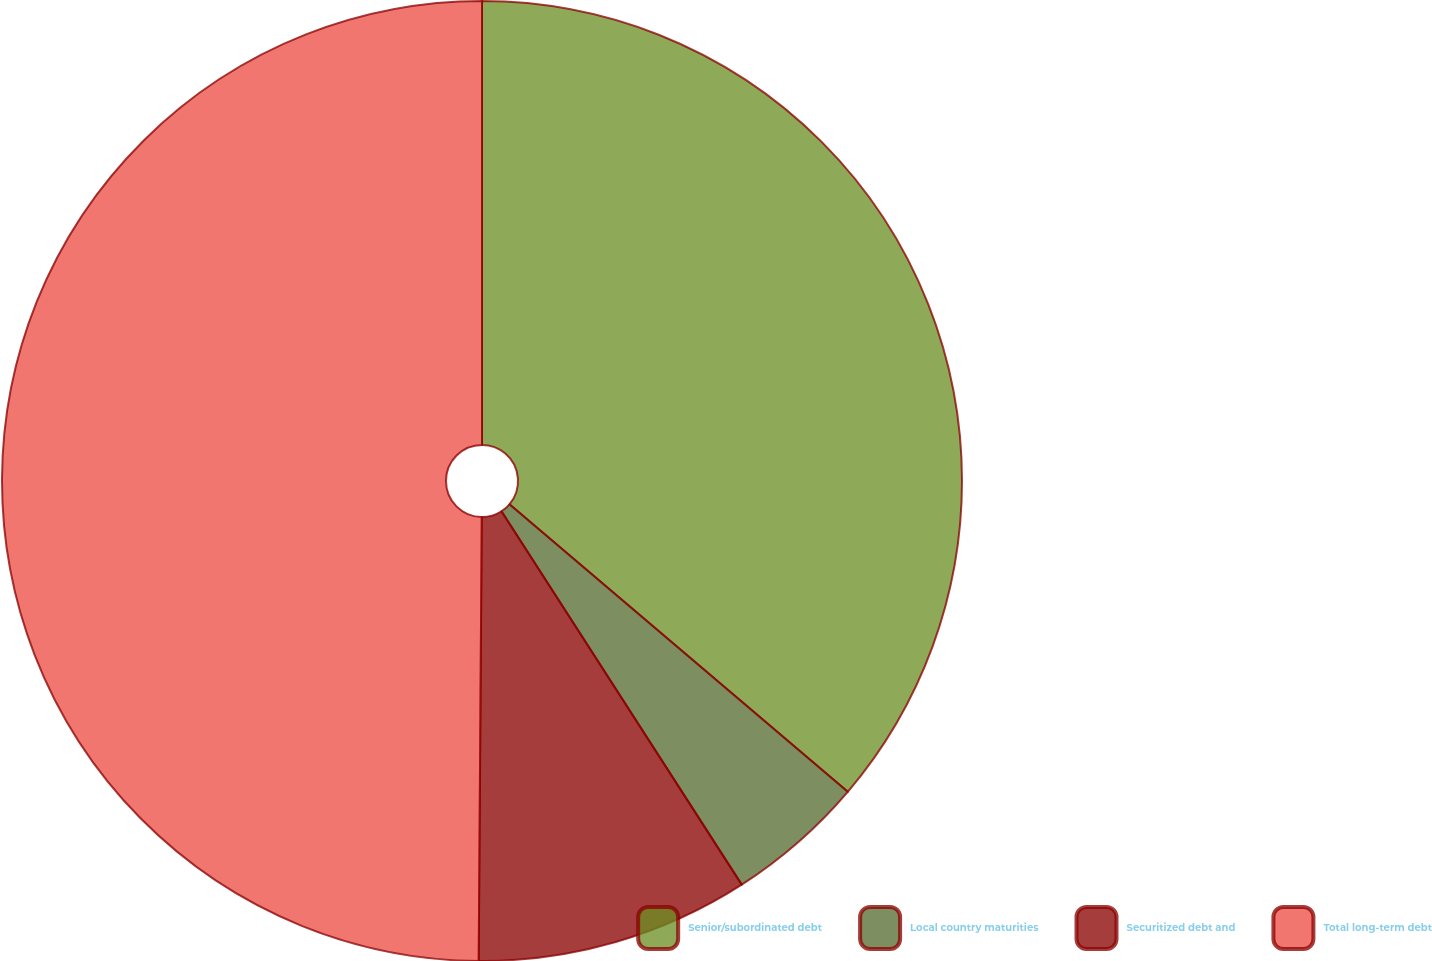Convert chart. <chart><loc_0><loc_0><loc_500><loc_500><pie_chart><fcel>Senior/subordinated debt<fcel>Local country maturities<fcel>Securitized debt and<fcel>Total long-term debt<nl><fcel>36.21%<fcel>4.69%<fcel>9.21%<fcel>49.89%<nl></chart> 